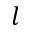<formula> <loc_0><loc_0><loc_500><loc_500>l</formula> 